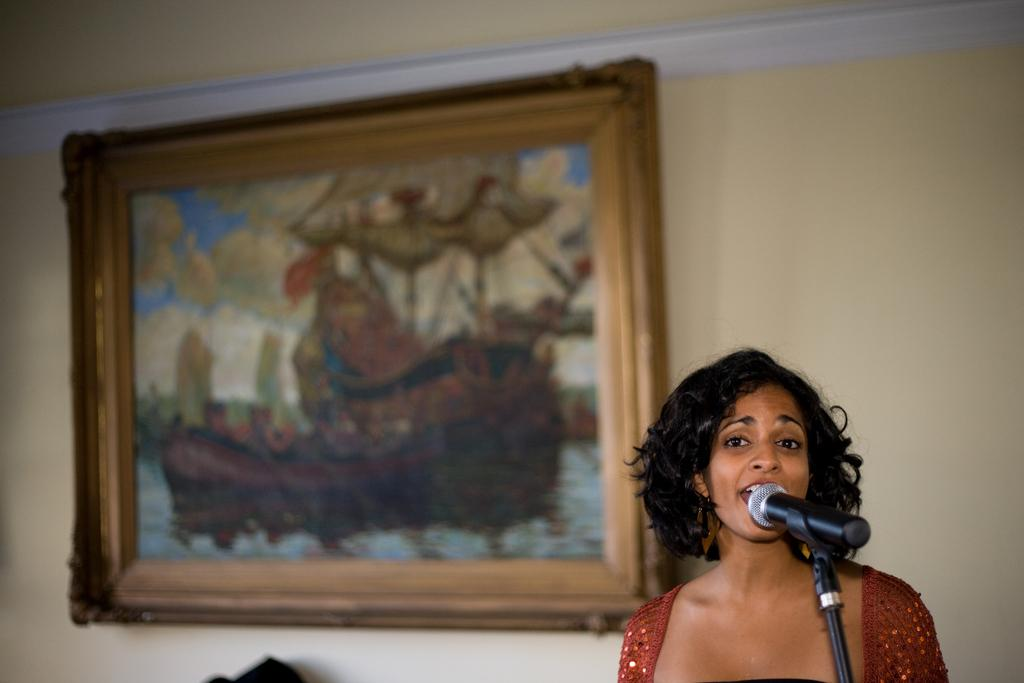What is the main subject of the image? There is a woman in the image. What is the woman doing in the image? The woman is singing a song. What object is in front of the woman? There is a microphone in front of the woman. What can be seen in the background of the image? There is a wall in the background of the image. Are there any decorative elements on the wall? Yes, there is a photo frame attached to the wall in the background. How many ducks are visible in the image? There are no ducks present in the image. What color are the woman's feet in the image? The provided facts do not mention the color of the woman's feet, so we cannot determine that information from the image. 